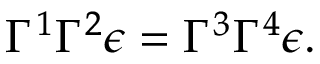Convert formula to latex. <formula><loc_0><loc_0><loc_500><loc_500>\Gamma ^ { 1 } \Gamma ^ { 2 } \epsilon = \Gamma ^ { 3 } \Gamma ^ { 4 } \epsilon .</formula> 